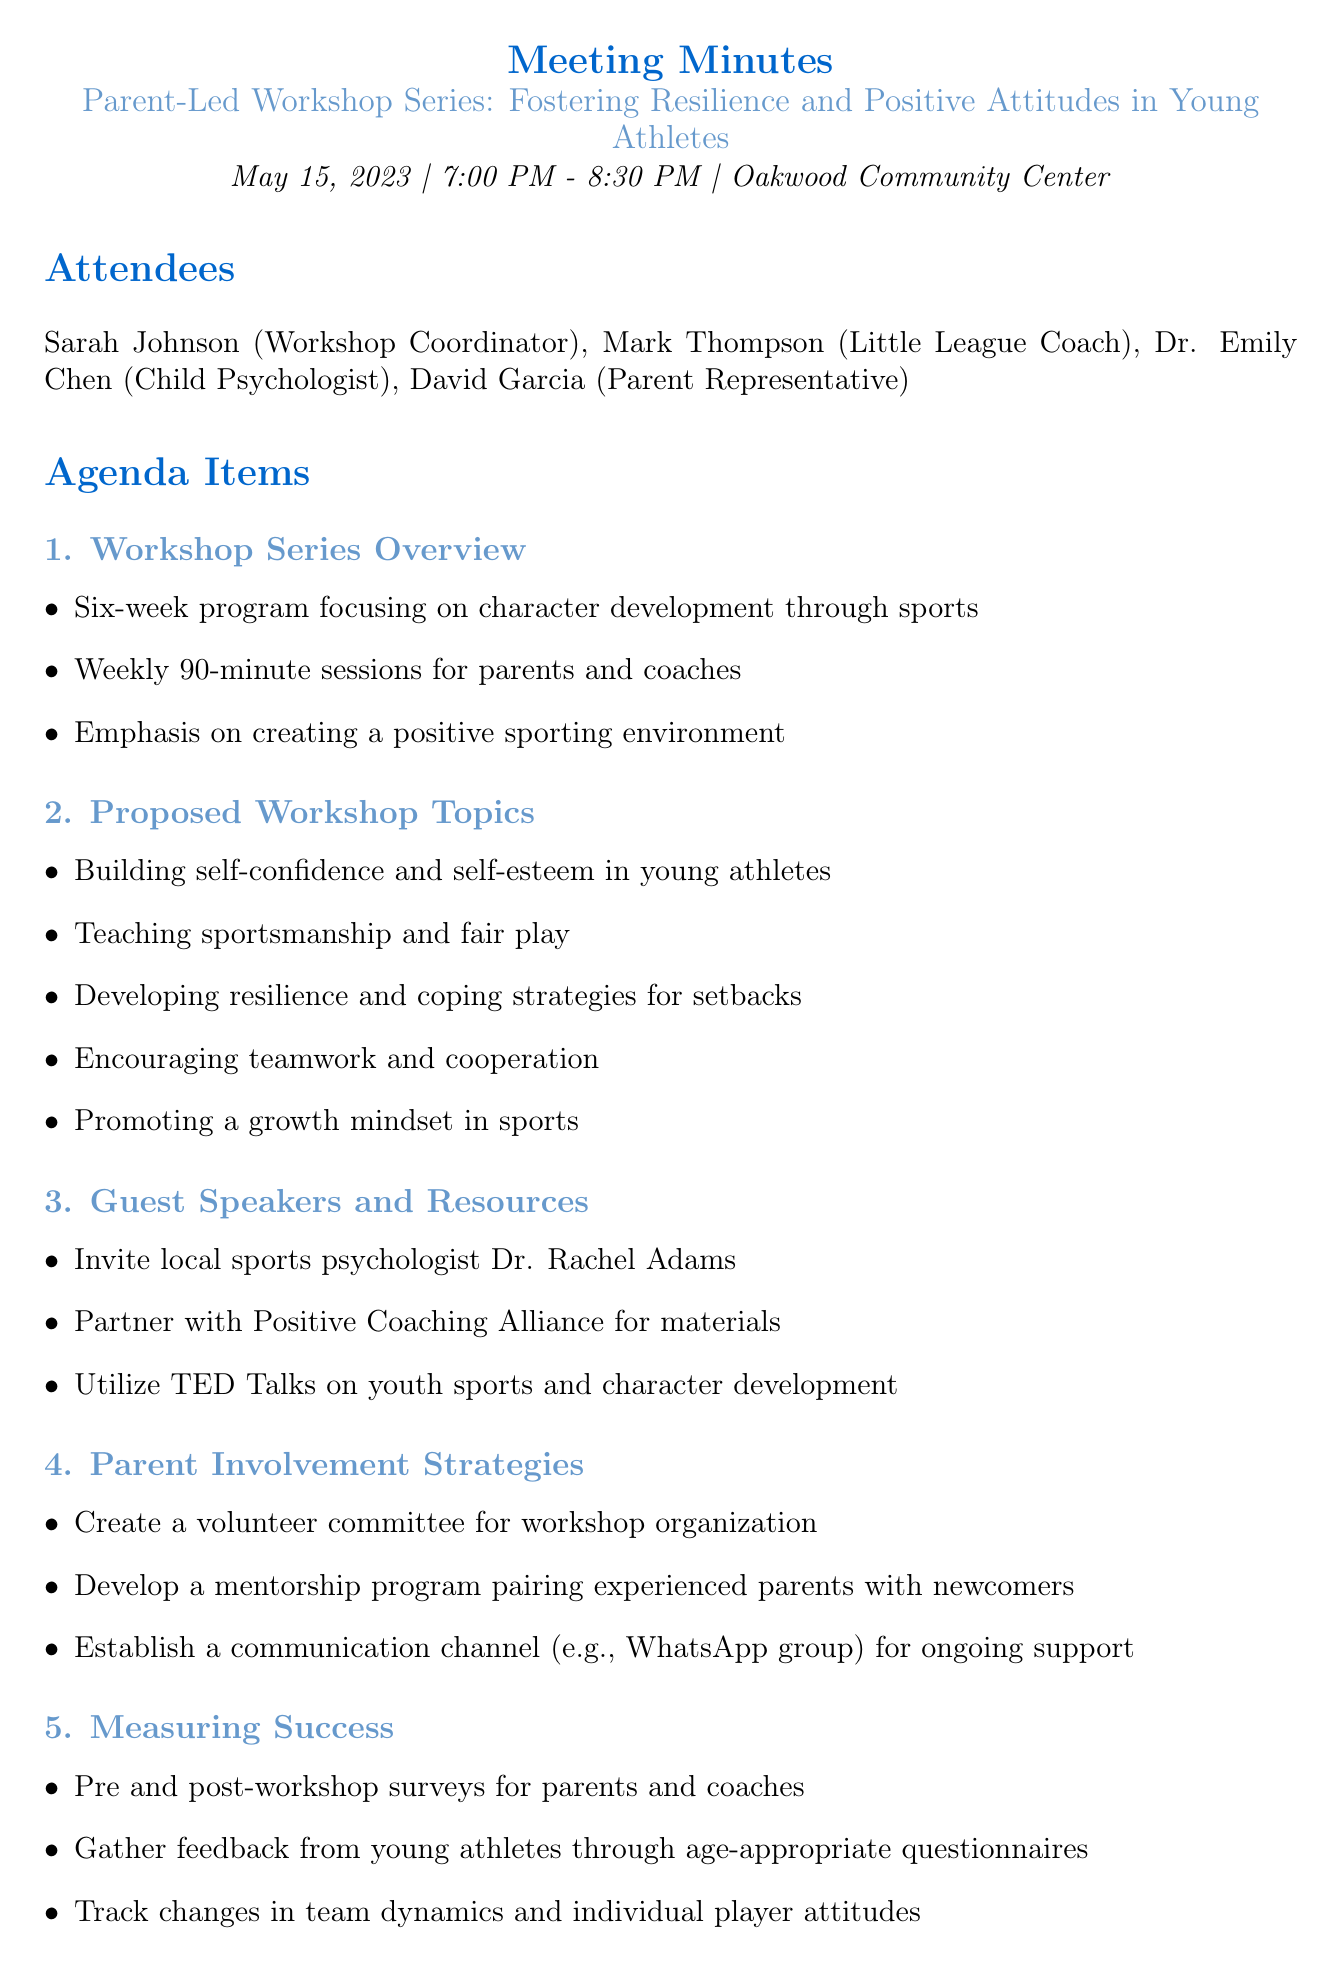what is the date of the meeting? The date of the meeting is specified in the document as May 15, 2023.
Answer: May 15, 2023 who is the workshop coordinator? The document lists Sarah Johnson as the Workshop Coordinator.
Answer: Sarah Johnson how long is each workshop session? The key points indicate that each session will last for 90 minutes.
Answer: 90 minutes what are the proposed workshop topics? The key points under this section include multiple topics, but a concise topic would be "Building self-confidence and self-esteem in young athletes."
Answer: Building self-confidence and self-esteem in young athletes how will success be measured? The document outlines several methods for measuring success, one being "Pre and post-workshop surveys for parents and coaches."
Answer: Pre and post-workshop surveys for parents and coaches who is invited as a guest speaker? The document mentions Dr. Rachel Adams as a potential guest speaker.
Answer: Dr. Rachel Adams when is the next meeting scheduled? The next meeting is scheduled for June 1, 2023.
Answer: June 1, 2023 what is the focus of the workshop series? The focus of the workshop series is described as character development through sports.
Answer: Character development through sports how will parent involvement be enhanced? A key strategy mentioned is "Create a volunteer committee for workshop organization."
Answer: Create a volunteer committee for workshop organization 